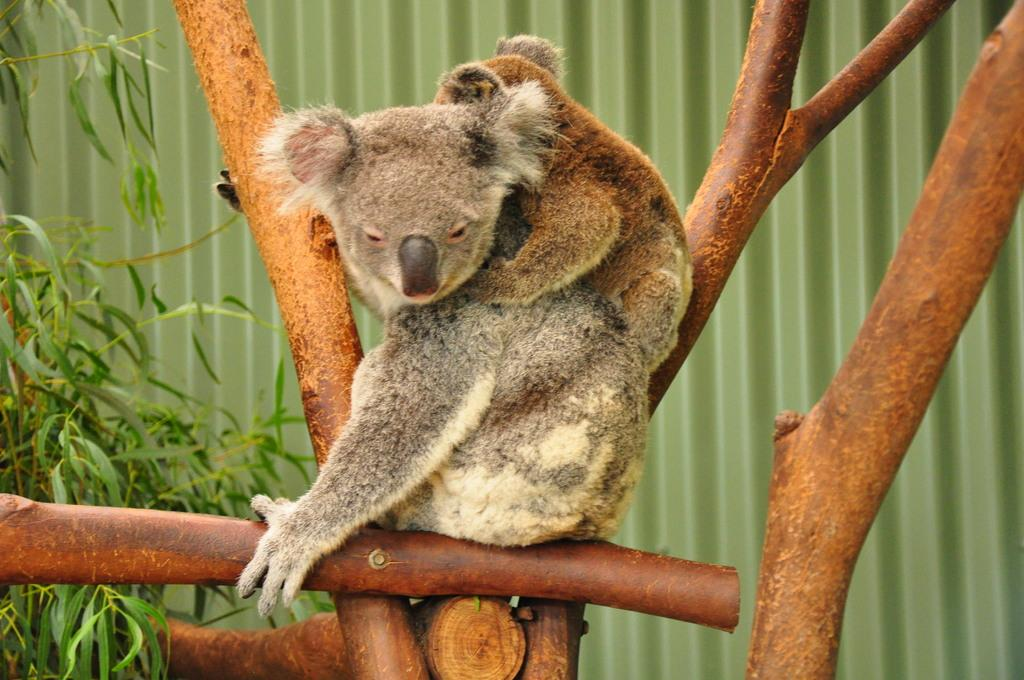What type of material is the panel in the background of the image made of? The panel in the background of the image is made of metal. What can be seen in the image besides the metal panel? There are animals and branches visible in the image. What type of vegetation is present on the left side of the image? There are green leaves on the left side of the image. What type of advice is the desk giving in the image? There is no desk present in the image, so it cannot provide any advice. 